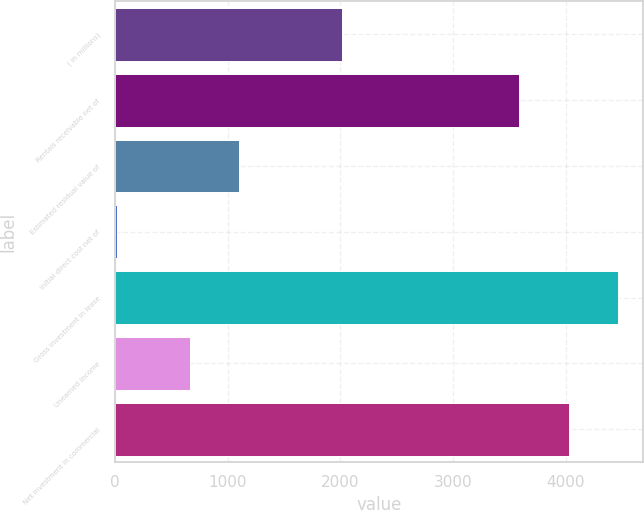Convert chart to OTSL. <chart><loc_0><loc_0><loc_500><loc_500><bar_chart><fcel>( in millions)<fcel>Rentals receivable net of<fcel>Estimated residual value of<fcel>Initial direct cost net of<fcel>Gross investment in lease<fcel>Unearned income<fcel>Net investment in commercial<nl><fcel>2014<fcel>3589<fcel>1101.8<fcel>17<fcel>4462.6<fcel>665<fcel>4025.8<nl></chart> 